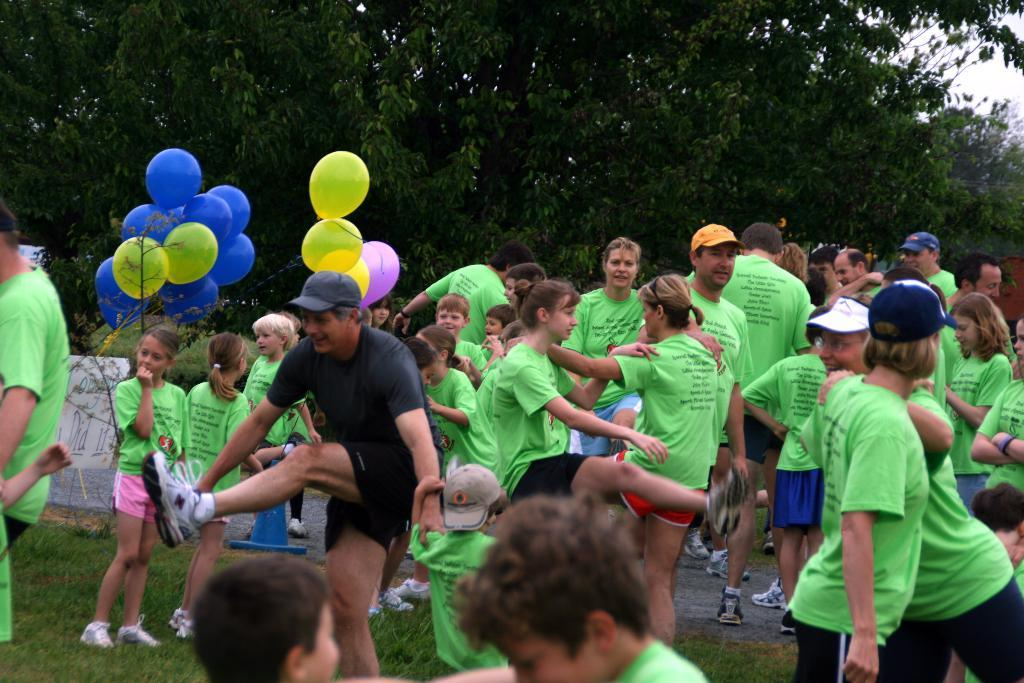What can be seen in the image involving multiple individuals? There is a group of people in the image. What additional objects are present in the image? There are balloons and trees in the image. What type of surface are the people standing on? The group of people are standing on the grass. What is visible in the background of the image? The sky is visible in the background of the image. Can you see any jellyfish swimming in the image? No, there are no jellyfish present in the image. Are there any parents in the image? The provided facts do not mention the presence of parents in the image. 